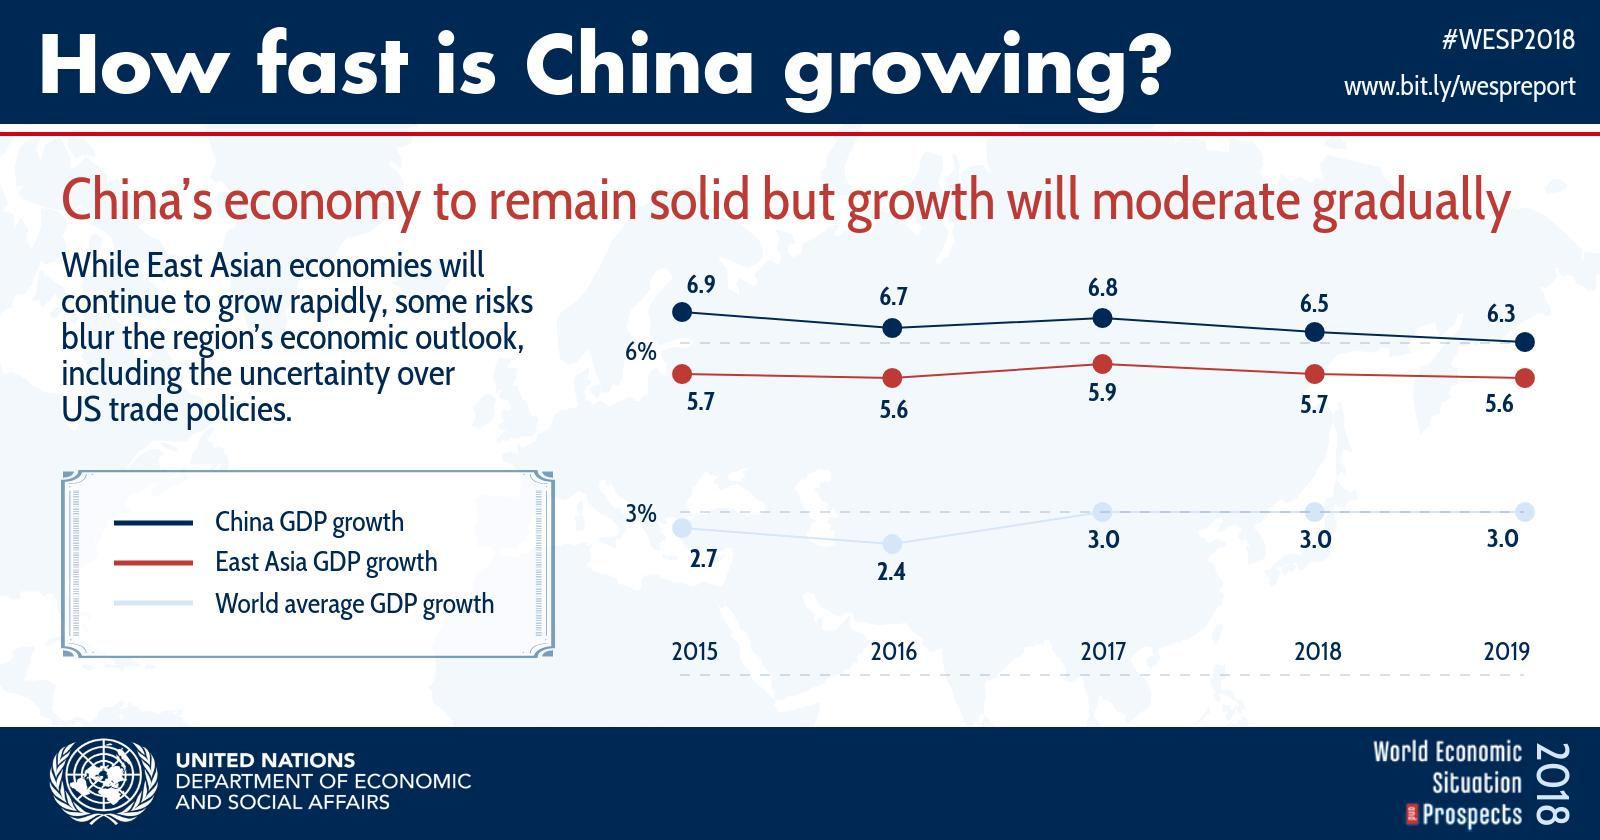Identify some key points in this picture. In 2016, the Gross Domestic Product (GDP) growth in China was significantly higher than the average GDP growth rate of the world. Specifically, the GDP growth in China was 4.3%, while the worldwide average GDP growth was approximately 3.2%. In 2019, the Gross Domestic Product (GDP) growth in China was 6.1%, while the GDP growth in East Asia as a whole was 5.3%. This indicates that the economic performance of China was stronger than that of East Asia as a whole, with a difference of 0.7%. In 2018, the Gross Domestic Product (GDP) growth in China was significantly higher than the average GDP growth of the world. Specifically, the GDP growth in China was 3.5%, while the average GDP growth of the world was X%. In 2019, the GDP growth in China was significantly higher than the world average GDP growth. Specifically, the GDP growth in China was 3.3%, while the world average GDP growth was X%. The GDP growth in China and East Asia in 2016 was 9%. 